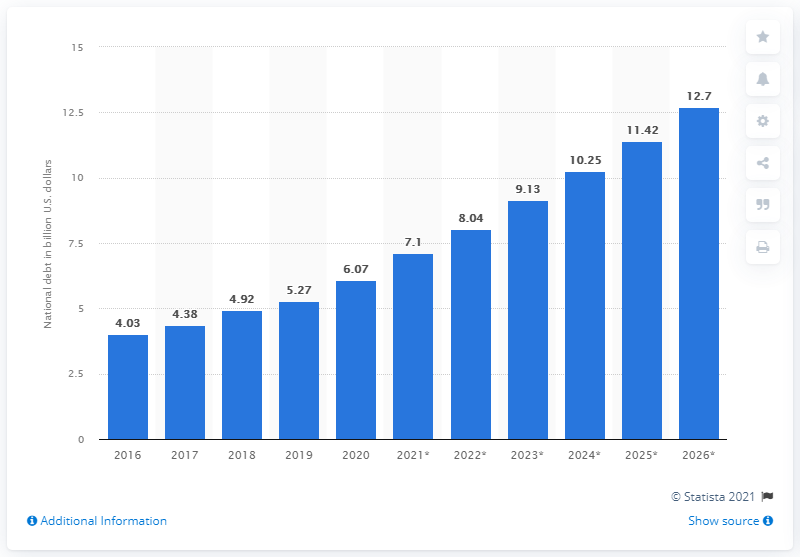Specify some key components in this picture. In the year 2020, the national debt of Madagascar came to an end. The national debt of Madagascar in dollars in 2020 was approximately 6.07. The national debt of Madagascar was resolved in the year 2020. 